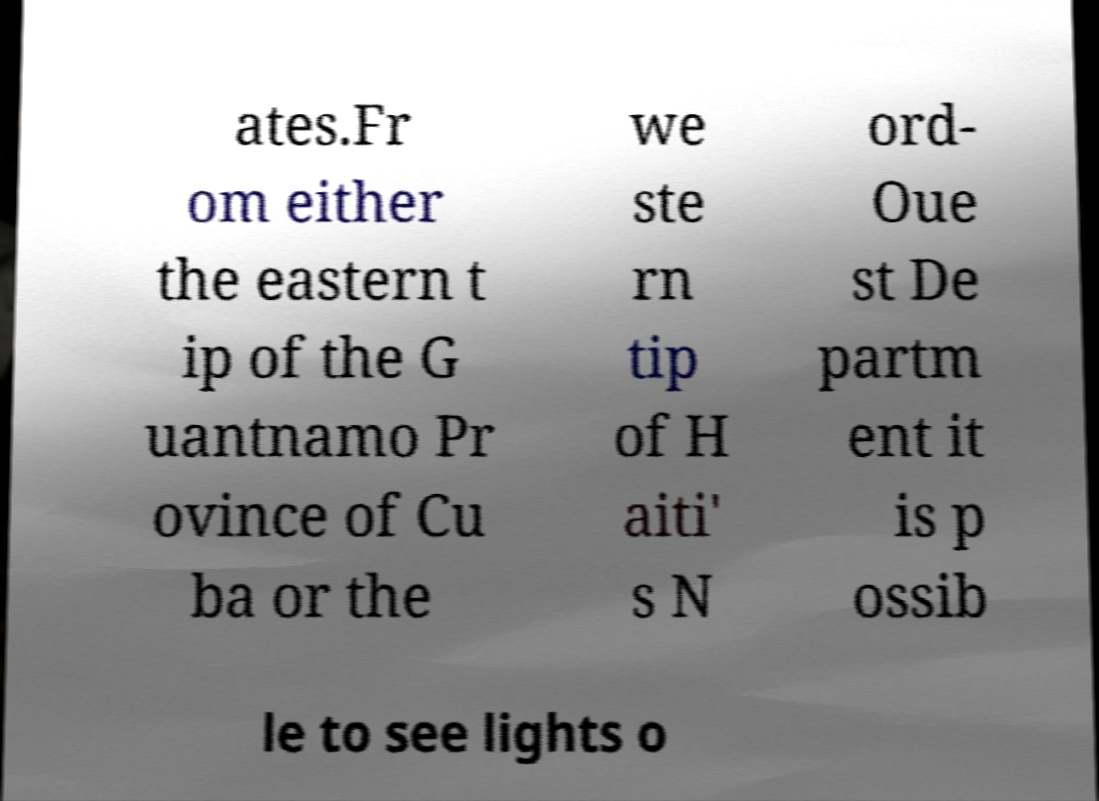For documentation purposes, I need the text within this image transcribed. Could you provide that? ates.Fr om either the eastern t ip of the G uantnamo Pr ovince of Cu ba or the we ste rn tip of H aiti' s N ord- Oue st De partm ent it is p ossib le to see lights o 